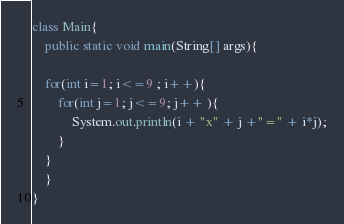Convert code to text. <code><loc_0><loc_0><loc_500><loc_500><_Java_>class Main{
	public static void main(String[] args){
	
	for(int i=1; i<=9 ; i++){
		for(int j=1; j<=9; j++ ){
			System.out.println(i + "x" + j +"=" + i*j);
		}
	}
	}
}</code> 